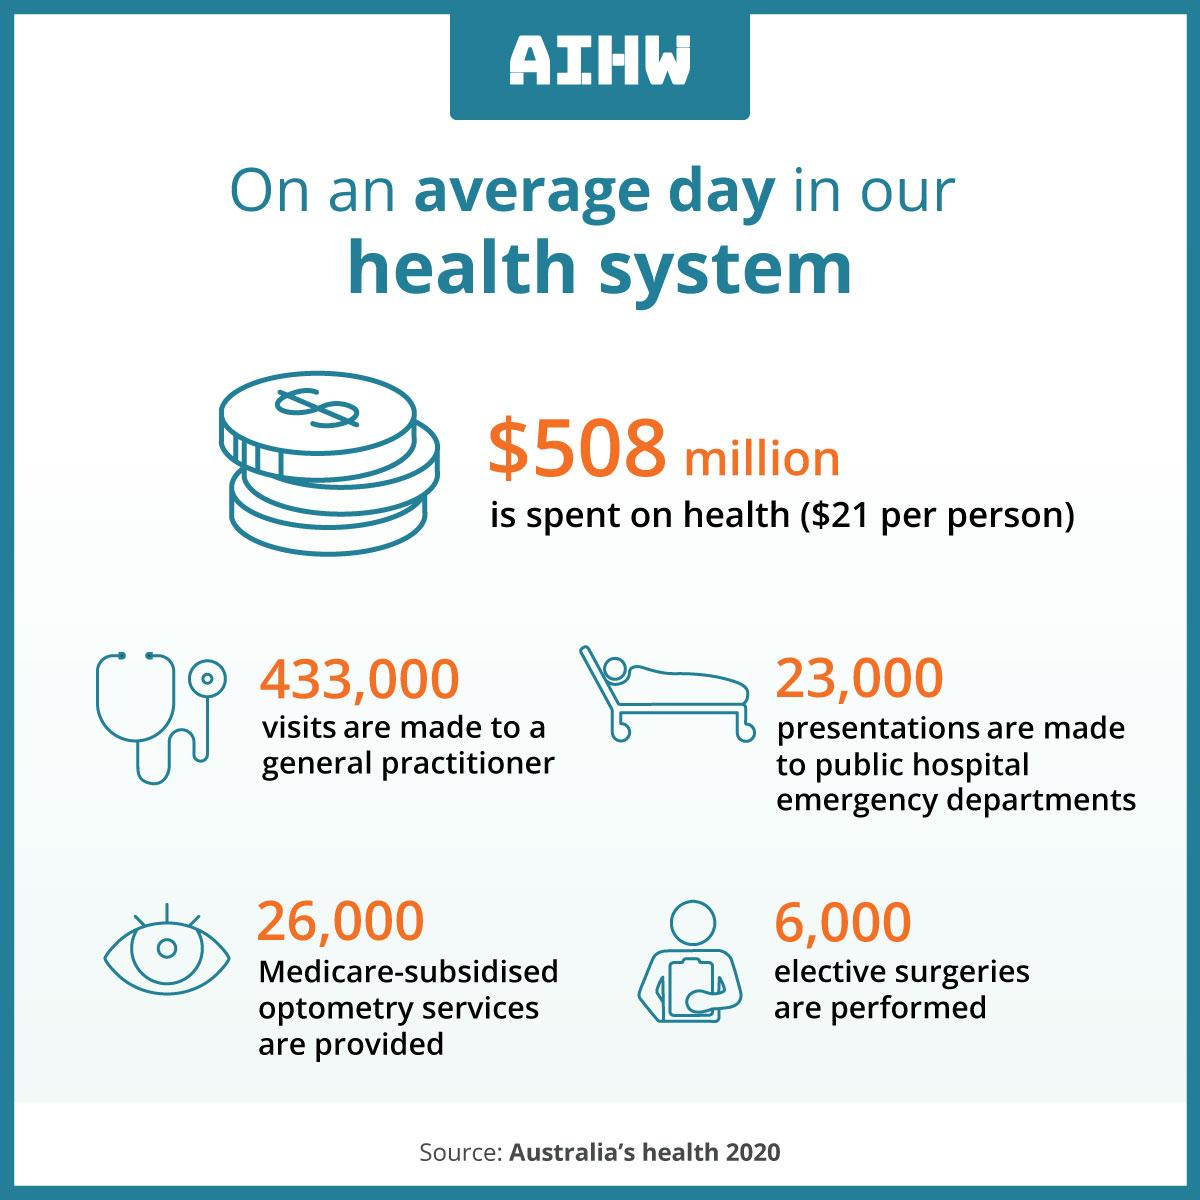Mention a couple of crucial points in this snapshot. On an average day, approximately 6,000 elective surgeries are performed in the Australian Institute of Health and Welfare (AIHW). On an average day, approximately 433,000 visits are made to general practitioners in Australia, according to the Australian Institute of Health and Welfare. 